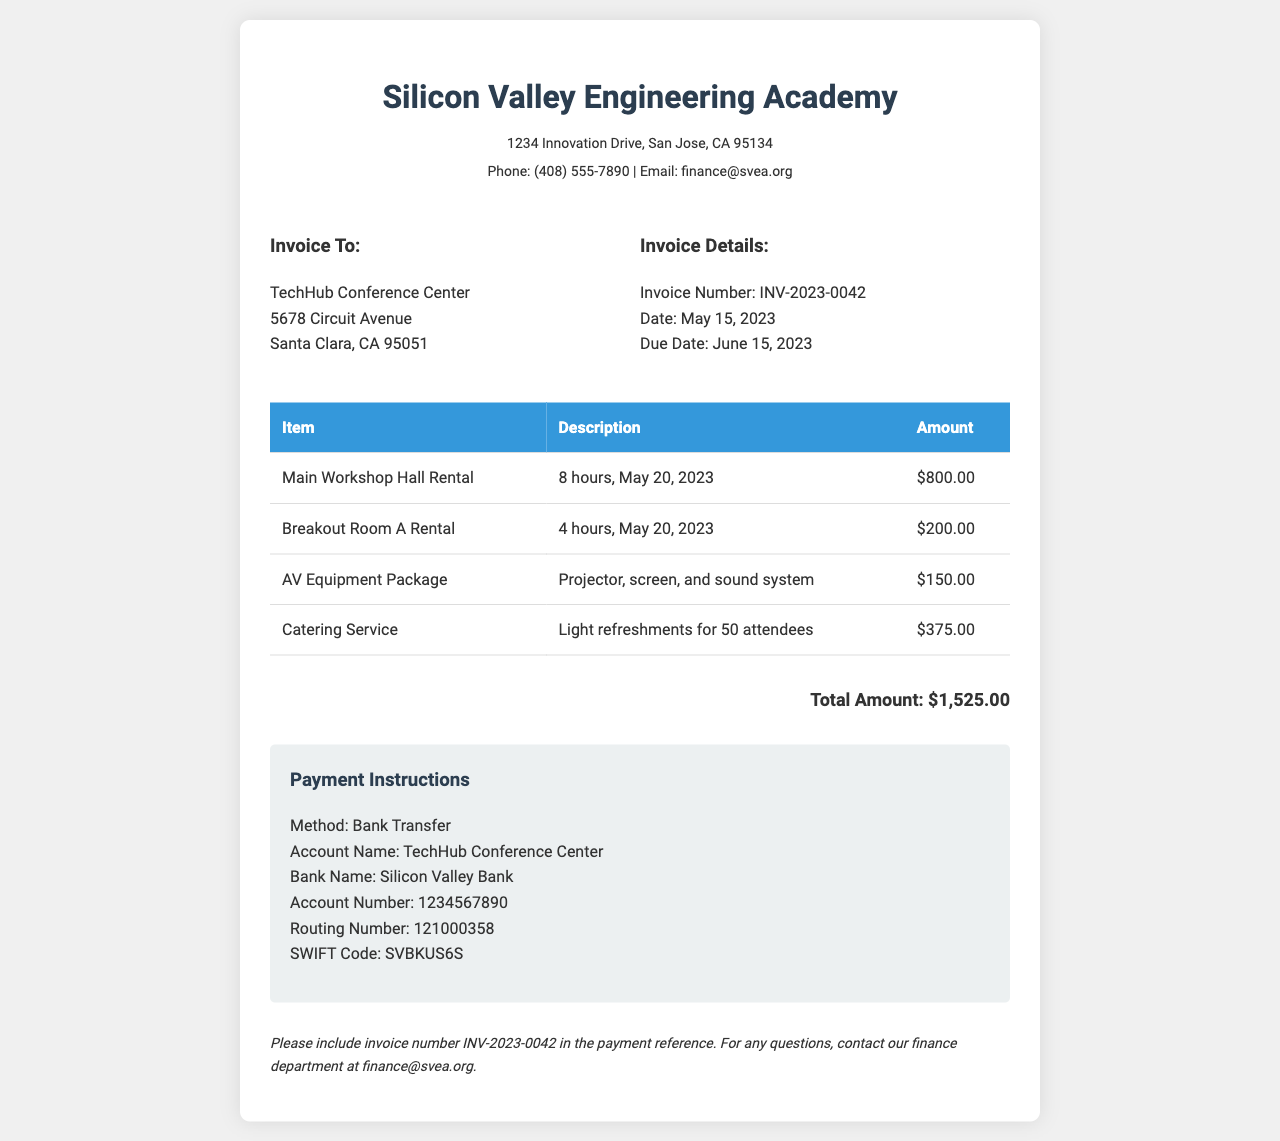What is the invoice number? The invoice number is clearly stated in the document as INV-2023-0042.
Answer: INV-2023-0042 What is the total amount due? The total amount due is listed at the bottom of the invoice as $1,525.00.
Answer: $1,525.00 When is the invoice due date? The due date for the invoice is provided in the document as June 15, 2023.
Answer: June 15, 2023 What is the name of the venue being rented? The name of the venue is specified as TechHub Conference Center.
Answer: TechHub Conference Center How many hours is the Main Workshop Hall Rental for? The document specifies that the Main Workshop Hall Rental is for 8 hours.
Answer: 8 hours What is included in the AV Equipment Package? The AV Equipment Package includes a projector, screen, and sound system, as described in the invoice.
Answer: Projector, screen, and sound system What payment method is requested? The invoice states that the payment method requested is Bank Transfer.
Answer: Bank Transfer What is the account number for the payment? The account number for the payment is detailed as 1234567890 in the document.
Answer: 1234567890 How many attendees are catered for? The document mentions that the light refreshments are for 50 attendees.
Answer: 50 attendees 